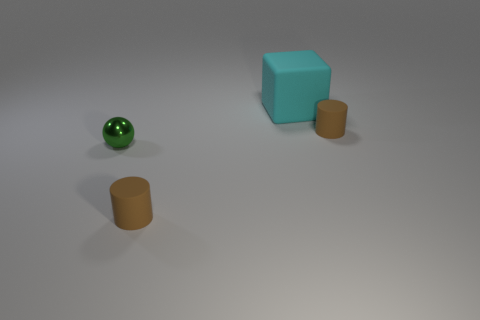Is there any other thing that has the same material as the green sphere?
Your answer should be compact. No. There is a brown matte cylinder that is right of the small brown rubber cylinder in front of the small object to the right of the block; what size is it?
Provide a short and direct response. Small. The large object has what color?
Your response must be concise. Cyan. Are there more cylinders that are to the left of the big cyan matte cube than tiny brown cylinders?
Provide a short and direct response. No. There is a large cyan matte block; how many balls are to the left of it?
Give a very brief answer. 1. There is a tiny brown cylinder in front of the cylinder that is behind the metal thing; is there a small object in front of it?
Offer a terse response. No. Do the green object and the cyan rubber object have the same size?
Keep it short and to the point. No. Are there the same number of tiny green objects that are behind the large object and cylinders that are in front of the metallic sphere?
Provide a short and direct response. No. What is the shape of the small metallic thing that is on the left side of the large cyan thing?
Provide a short and direct response. Sphere. What is the color of the small object that is right of the tiny brown cylinder in front of the matte object that is to the right of the large rubber cube?
Provide a short and direct response. Brown. 